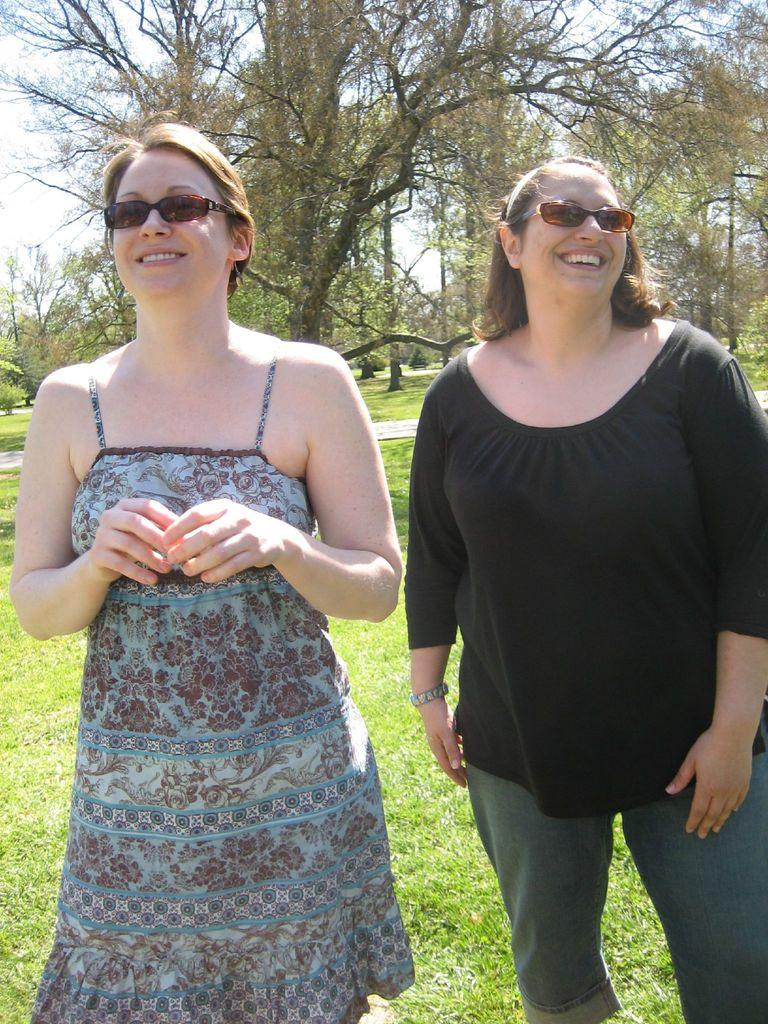What is the main subject of the image? There is a woman standing in the image. What is the woman standing on? The woman is standing on the ground. What can be seen in the background of the image? There are trees and the sky visible in the background of the image. What type of rings can be seen on the woman's fingers in the image? There are no rings visible on the woman's fingers in the image. What message is the woman conveying as she says good-bye in the image? There is no indication of a good-bye or any message being conveyed in the image. 